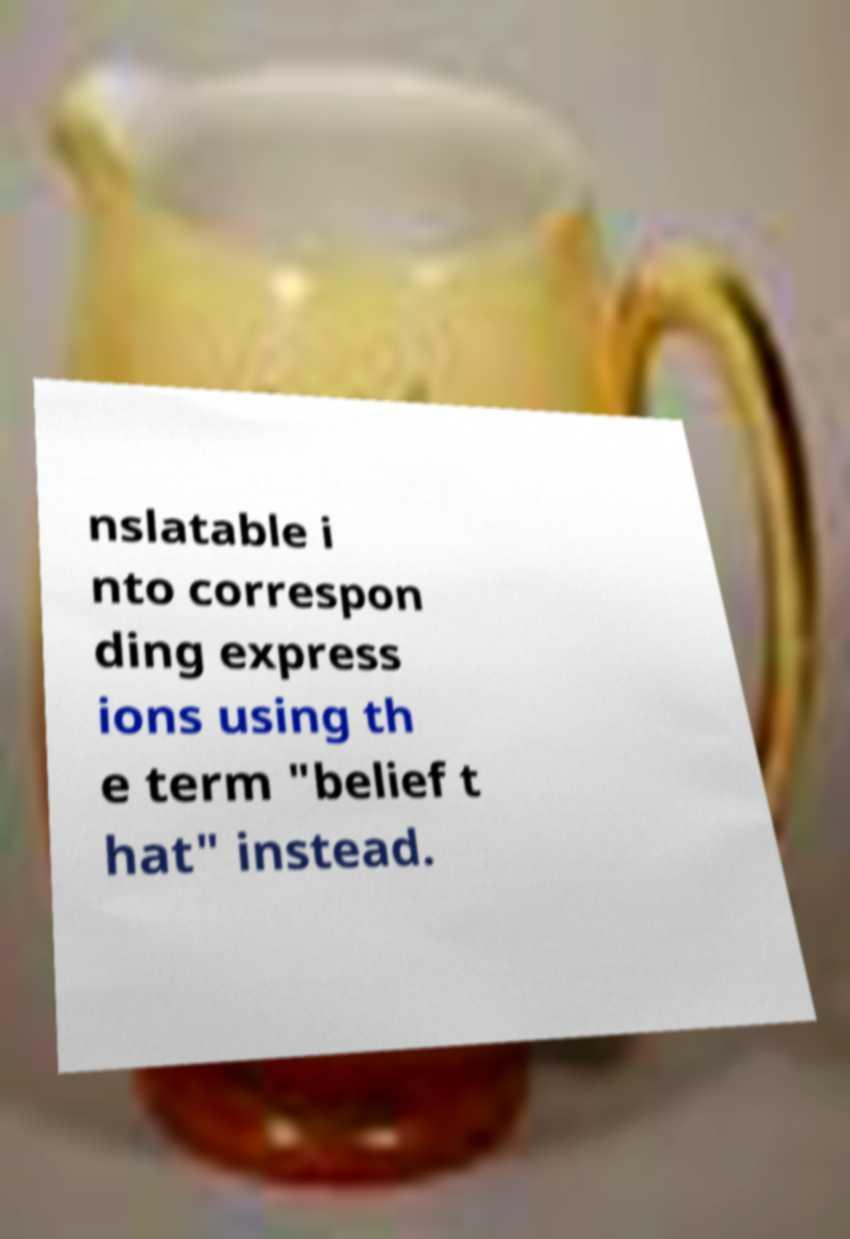Could you assist in decoding the text presented in this image and type it out clearly? nslatable i nto correspon ding express ions using th e term "belief t hat" instead. 